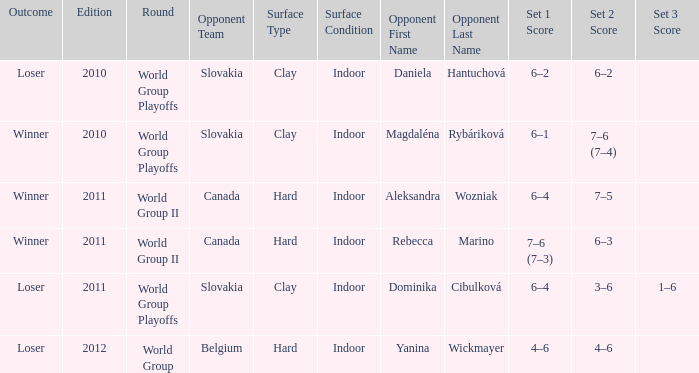When playing against dominika cibulková, what was the result of the game? 6–4, 3–6, 1–6. 